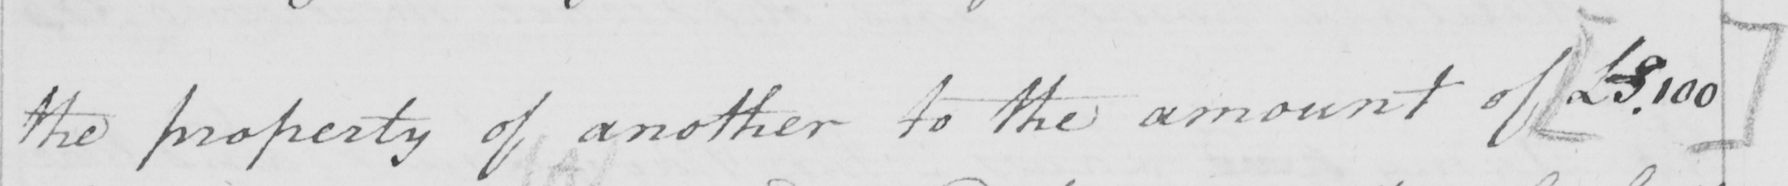What does this handwritten line say? the property of another to the amount of  [  £ 3.100 ] 